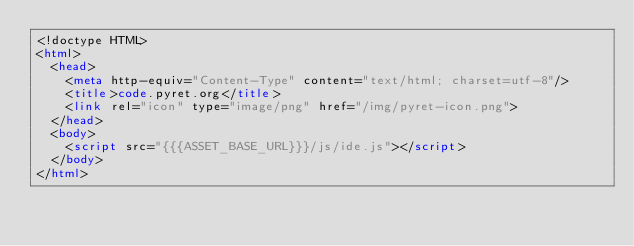<code> <loc_0><loc_0><loc_500><loc_500><_HTML_><!doctype HTML>
<html>
  <head>
    <meta http-equiv="Content-Type" content="text/html; charset=utf-8"/>
    <title>code.pyret.org</title>
    <link rel="icon" type="image/png" href="/img/pyret-icon.png">
  </head>
  <body>
    <script src="{{{ASSET_BASE_URL}}}/js/ide.js"></script>
  </body>
</html>
</code> 